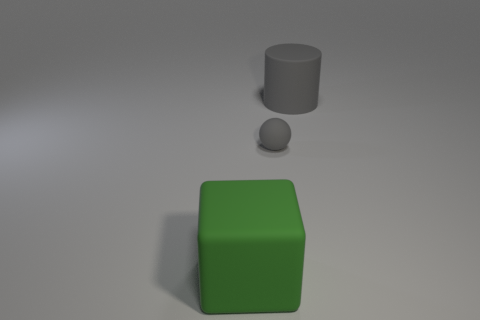Is the color of the ball the same as the large matte cylinder?
Your answer should be very brief. Yes. There is a large rubber cylinder; is its color the same as the tiny rubber ball that is to the left of the big gray cylinder?
Give a very brief answer. Yes. Is there a gray matte object that has the same size as the green matte cube?
Give a very brief answer. Yes. There is a thing that is the same color as the big cylinder; what is its size?
Ensure brevity in your answer.  Small. There is a gray thing that is behind the small rubber sphere; what material is it?
Provide a short and direct response. Rubber. Are there the same number of large gray matte cylinders in front of the large gray rubber cylinder and tiny gray rubber spheres that are to the left of the big rubber block?
Provide a short and direct response. Yes. There is a gray thing that is behind the small matte ball; does it have the same size as the matte object in front of the tiny gray rubber object?
Provide a short and direct response. Yes. What number of matte cubes have the same color as the tiny object?
Offer a very short reply. 0. There is a large cylinder that is the same color as the ball; what material is it?
Offer a terse response. Rubber. Is the number of gray objects that are behind the block greater than the number of large rubber things?
Your response must be concise. No. 